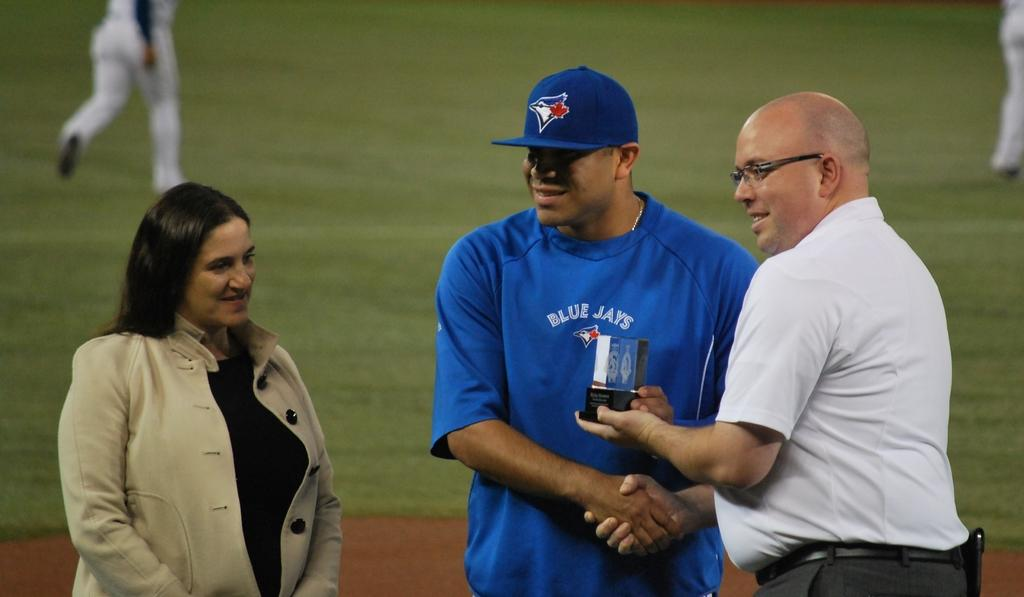<image>
Offer a succinct explanation of the picture presented. a man from the blue jays receiving an award from another man in a white shirt 